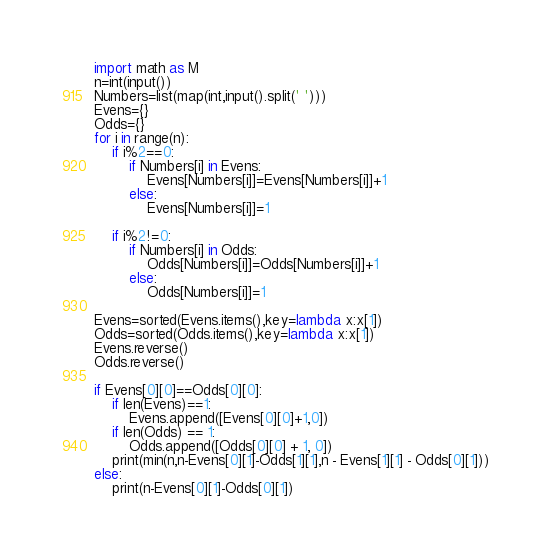<code> <loc_0><loc_0><loc_500><loc_500><_Python_>import math as M
n=int(input())
Numbers=list(map(int,input().split(' ')))
Evens={}
Odds={}
for i in range(n):
    if i%2==0:
        if Numbers[i] in Evens:
            Evens[Numbers[i]]=Evens[Numbers[i]]+1
        else:
            Evens[Numbers[i]]=1

    if i%2!=0:
        if Numbers[i] in Odds:
            Odds[Numbers[i]]=Odds[Numbers[i]]+1
        else:
            Odds[Numbers[i]]=1

Evens=sorted(Evens.items(),key=lambda x:x[1])
Odds=sorted(Odds.items(),key=lambda x:x[1])
Evens.reverse()
Odds.reverse()

if Evens[0][0]==Odds[0][0]:
    if len(Evens)==1:
        Evens.append([Evens[0][0]+1,0])
    if len(Odds) == 1:
        Odds.append([Odds[0][0] + 1, 0])
    print(min(n,n-Evens[0][1]-Odds[1][1],n - Evens[1][1] - Odds[0][1]))
else:
    print(n-Evens[0][1]-Odds[0][1])</code> 